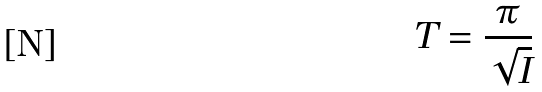<formula> <loc_0><loc_0><loc_500><loc_500>T = \frac { \pi } { \sqrt { I } }</formula> 